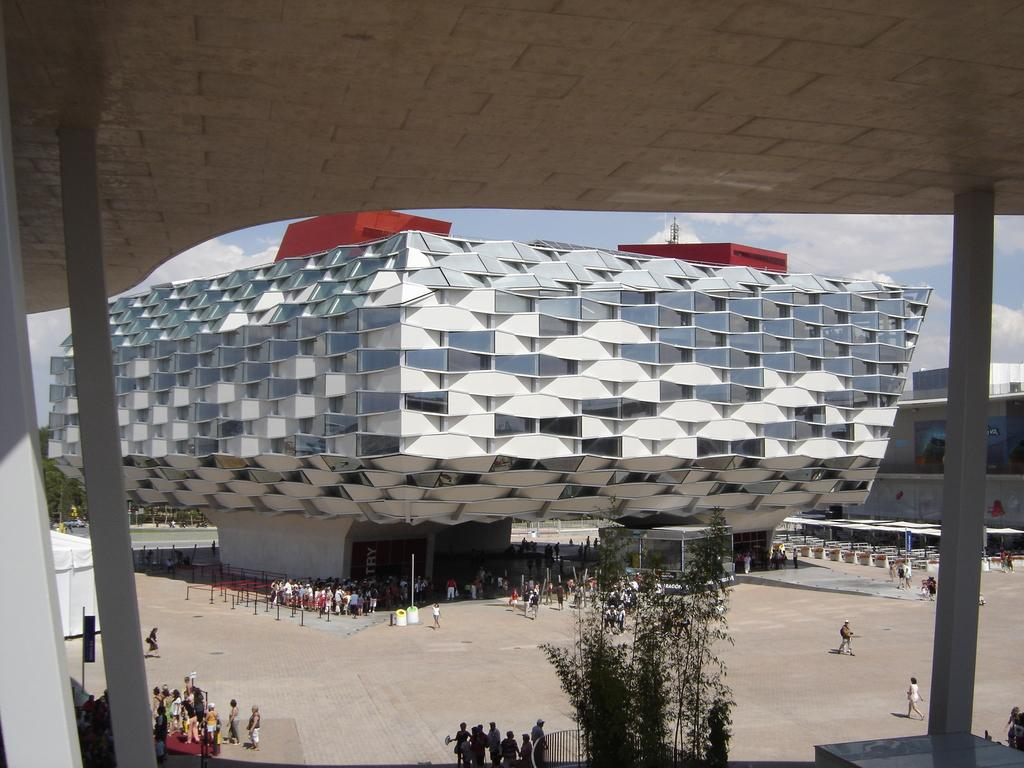What type of structures can be seen in the image? There are buildings in the image. What other natural elements are present in the image? There are trees in the image. What are the vertical objects in the image? There are poles in the image. Are there any living beings in the image? Yes, there are people in the image. What is the color of the sky in the image? The sky is blue and white in color. What type of soap is being used by the people in the image? There is no soap present in the image; it features buildings, trees, poles, and people. What book is being read by the trees in the image? There are no books or trees reading in the image; it only shows buildings, trees, poles, and people. 